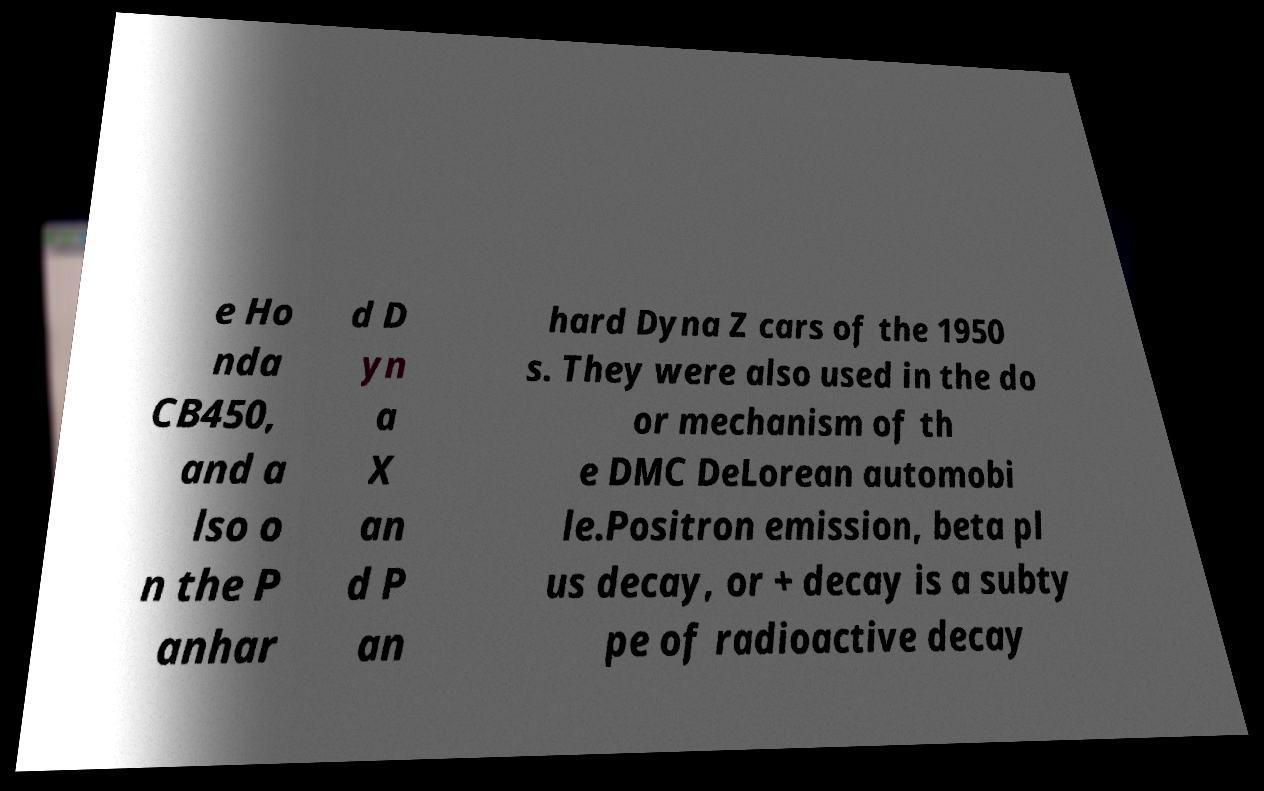Please read and relay the text visible in this image. What does it say? e Ho nda CB450, and a lso o n the P anhar d D yn a X an d P an hard Dyna Z cars of the 1950 s. They were also used in the do or mechanism of th e DMC DeLorean automobi le.Positron emission, beta pl us decay, or + decay is a subty pe of radioactive decay 